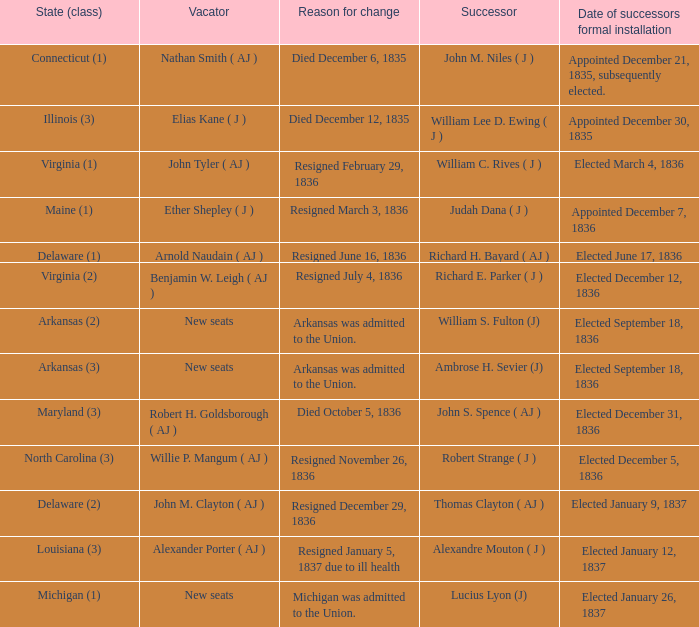Name the person who succeeded on january 26, 183 1.0. 